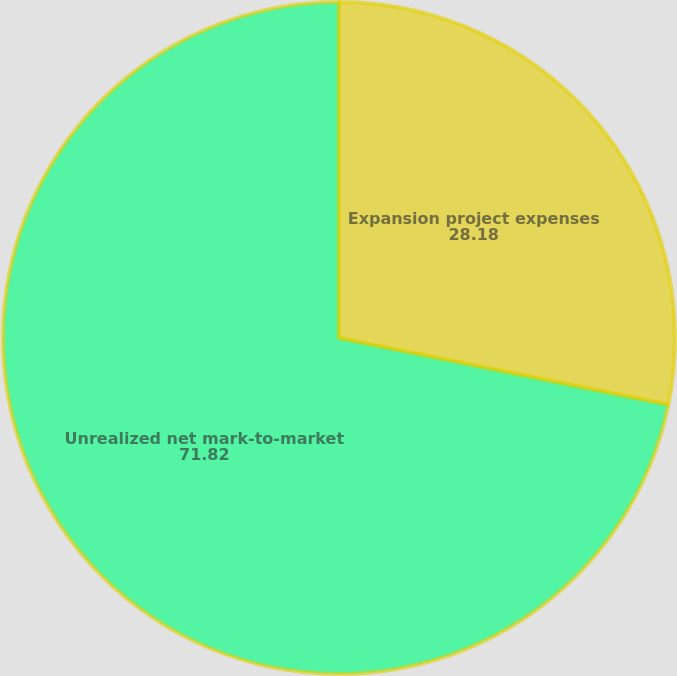<chart> <loc_0><loc_0><loc_500><loc_500><pie_chart><fcel>Expansion project expenses<fcel>Unrealized net mark-to-market<nl><fcel>28.18%<fcel>71.82%<nl></chart> 